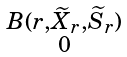<formula> <loc_0><loc_0><loc_500><loc_500>\begin{smallmatrix} B ( r , \widetilde { X } _ { r } , \widetilde { S } _ { r } ) \\ 0 \end{smallmatrix}</formula> 